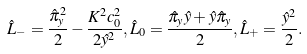<formula> <loc_0><loc_0><loc_500><loc_500>\hat { L } _ { - } = \frac { \hat { \pi } _ { y } ^ { 2 } } { 2 } - \frac { K ^ { 2 } c _ { 0 } ^ { 2 } } { 2 \hat { y } ^ { 2 } } , \hat { L } _ { 0 } = \frac { \hat { \pi } _ { y } \hat { y } + \hat { y } \hat { \pi } _ { y } } { 2 } , \hat { L } _ { + } = \frac { \hat { y } ^ { 2 } } { 2 } .</formula> 